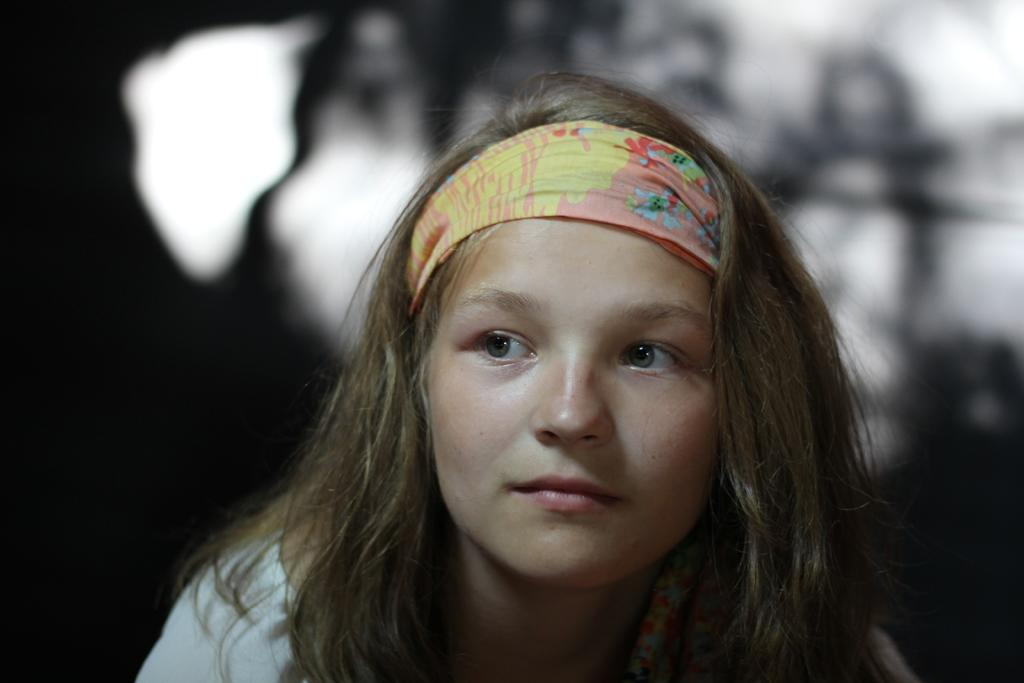Who is the main subject in the image? There is a girl in the image. What accessory is the girl wearing? The girl is wearing a hairband. Can you describe the background of the image? The background of the image is blurred. What type of cable can be seen in the image? There is no cable present in the image. Is there a beggar visible in the image? There is no beggar present in the image. What type of drink is being served in the image? There is no drink present in the image. 